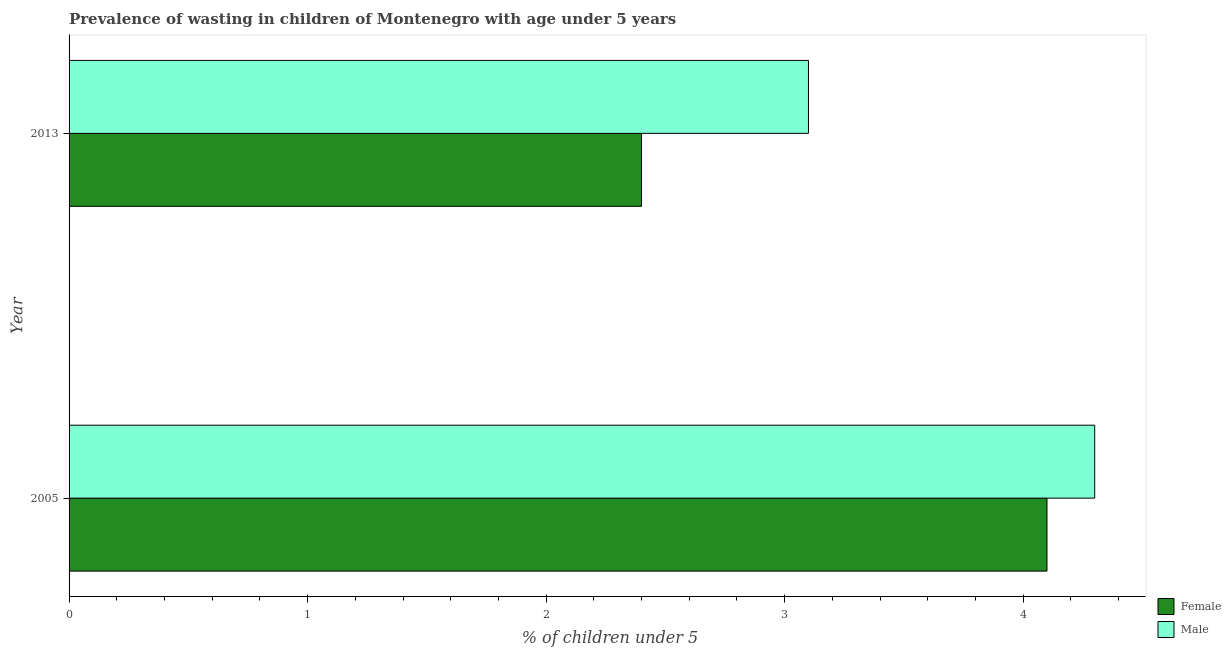How many different coloured bars are there?
Ensure brevity in your answer.  2. Are the number of bars on each tick of the Y-axis equal?
Keep it short and to the point. Yes. How many bars are there on the 2nd tick from the top?
Provide a succinct answer. 2. How many bars are there on the 2nd tick from the bottom?
Offer a terse response. 2. What is the label of the 1st group of bars from the top?
Your answer should be very brief. 2013. What is the percentage of undernourished male children in 2013?
Your answer should be compact. 3.1. Across all years, what is the maximum percentage of undernourished male children?
Your response must be concise. 4.3. Across all years, what is the minimum percentage of undernourished female children?
Your answer should be very brief. 2.4. In which year was the percentage of undernourished female children maximum?
Keep it short and to the point. 2005. In which year was the percentage of undernourished female children minimum?
Make the answer very short. 2013. What is the total percentage of undernourished female children in the graph?
Keep it short and to the point. 6.5. What is the difference between the percentage of undernourished female children in 2005 and the percentage of undernourished male children in 2013?
Ensure brevity in your answer.  1. What is the ratio of the percentage of undernourished female children in 2005 to that in 2013?
Offer a terse response. 1.71. Is the difference between the percentage of undernourished male children in 2005 and 2013 greater than the difference between the percentage of undernourished female children in 2005 and 2013?
Give a very brief answer. No. How many bars are there?
Give a very brief answer. 4. How many years are there in the graph?
Offer a very short reply. 2. Are the values on the major ticks of X-axis written in scientific E-notation?
Give a very brief answer. No. Does the graph contain any zero values?
Offer a terse response. No. Does the graph contain grids?
Provide a short and direct response. No. Where does the legend appear in the graph?
Provide a succinct answer. Bottom right. How are the legend labels stacked?
Ensure brevity in your answer.  Vertical. What is the title of the graph?
Your answer should be compact. Prevalence of wasting in children of Montenegro with age under 5 years. Does "From human activities" appear as one of the legend labels in the graph?
Your response must be concise. No. What is the label or title of the X-axis?
Ensure brevity in your answer.   % of children under 5. What is the label or title of the Y-axis?
Your answer should be very brief. Year. What is the  % of children under 5 of Female in 2005?
Your answer should be very brief. 4.1. What is the  % of children under 5 in Male in 2005?
Your response must be concise. 4.3. What is the  % of children under 5 in Female in 2013?
Your response must be concise. 2.4. What is the  % of children under 5 of Male in 2013?
Your answer should be compact. 3.1. Across all years, what is the maximum  % of children under 5 of Female?
Provide a succinct answer. 4.1. Across all years, what is the maximum  % of children under 5 in Male?
Ensure brevity in your answer.  4.3. Across all years, what is the minimum  % of children under 5 of Female?
Provide a succinct answer. 2.4. Across all years, what is the minimum  % of children under 5 of Male?
Provide a short and direct response. 3.1. What is the total  % of children under 5 of Female in the graph?
Your answer should be very brief. 6.5. What is the total  % of children under 5 of Male in the graph?
Ensure brevity in your answer.  7.4. What is the difference between the  % of children under 5 in Female in 2005 and that in 2013?
Provide a succinct answer. 1.7. What is the difference between the  % of children under 5 in Female in 2005 and the  % of children under 5 in Male in 2013?
Your response must be concise. 1. What is the average  % of children under 5 of Male per year?
Your answer should be very brief. 3.7. In the year 2013, what is the difference between the  % of children under 5 of Female and  % of children under 5 of Male?
Give a very brief answer. -0.7. What is the ratio of the  % of children under 5 in Female in 2005 to that in 2013?
Keep it short and to the point. 1.71. What is the ratio of the  % of children under 5 of Male in 2005 to that in 2013?
Provide a short and direct response. 1.39. What is the difference between the highest and the lowest  % of children under 5 of Male?
Give a very brief answer. 1.2. 